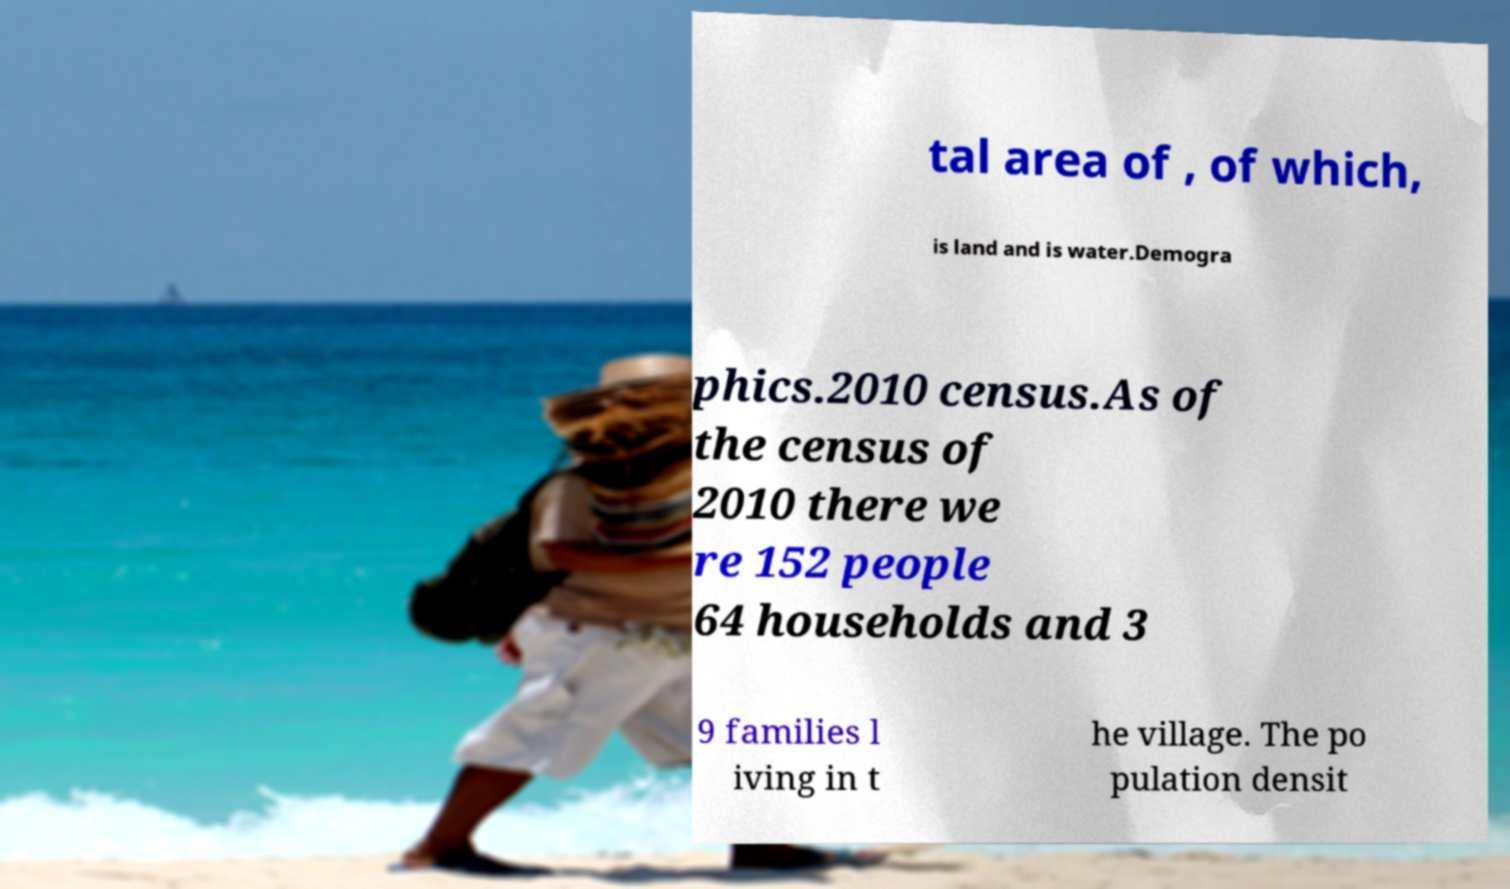Please read and relay the text visible in this image. What does it say? tal area of , of which, is land and is water.Demogra phics.2010 census.As of the census of 2010 there we re 152 people 64 households and 3 9 families l iving in t he village. The po pulation densit 